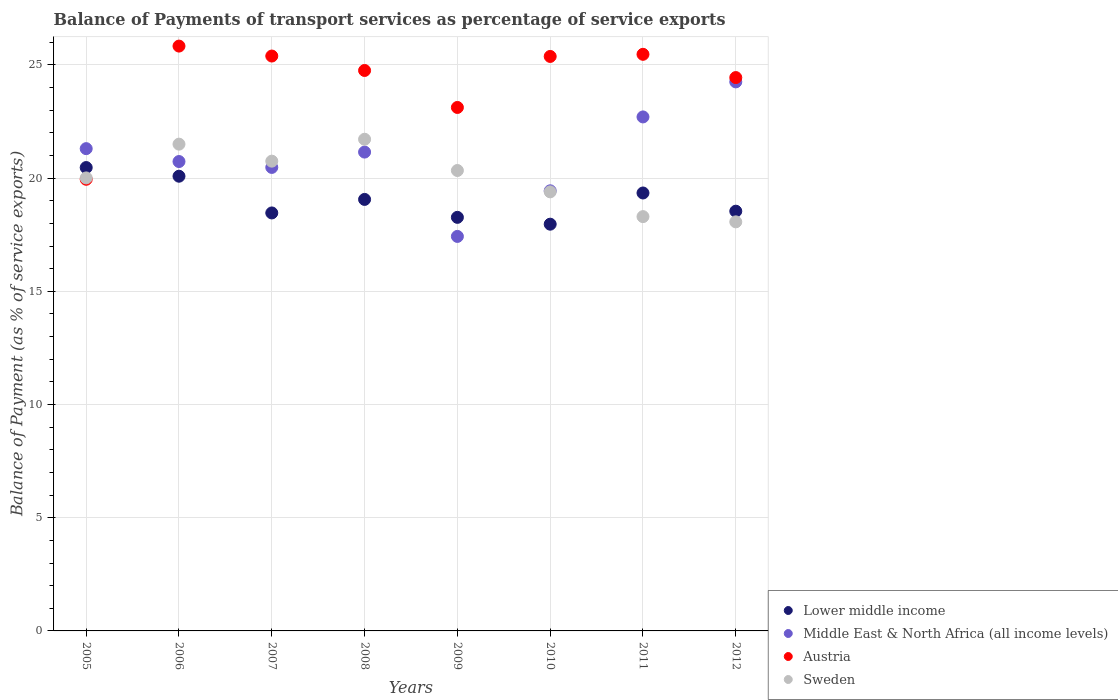What is the balance of payments of transport services in Austria in 2005?
Ensure brevity in your answer.  19.95. Across all years, what is the maximum balance of payments of transport services in Sweden?
Provide a succinct answer. 21.72. Across all years, what is the minimum balance of payments of transport services in Middle East & North Africa (all income levels)?
Keep it short and to the point. 17.43. What is the total balance of payments of transport services in Austria in the graph?
Make the answer very short. 194.33. What is the difference between the balance of payments of transport services in Lower middle income in 2006 and that in 2012?
Make the answer very short. 1.55. What is the difference between the balance of payments of transport services in Lower middle income in 2005 and the balance of payments of transport services in Middle East & North Africa (all income levels) in 2007?
Provide a short and direct response. -0.01. What is the average balance of payments of transport services in Middle East & North Africa (all income levels) per year?
Offer a very short reply. 20.93. In the year 2012, what is the difference between the balance of payments of transport services in Middle East & North Africa (all income levels) and balance of payments of transport services in Austria?
Offer a terse response. -0.19. What is the ratio of the balance of payments of transport services in Lower middle income in 2008 to that in 2012?
Provide a succinct answer. 1.03. Is the balance of payments of transport services in Austria in 2008 less than that in 2010?
Your answer should be very brief. Yes. Is the difference between the balance of payments of transport services in Middle East & North Africa (all income levels) in 2005 and 2010 greater than the difference between the balance of payments of transport services in Austria in 2005 and 2010?
Provide a short and direct response. Yes. What is the difference between the highest and the second highest balance of payments of transport services in Sweden?
Make the answer very short. 0.22. What is the difference between the highest and the lowest balance of payments of transport services in Sweden?
Your response must be concise. 3.65. Is the sum of the balance of payments of transport services in Middle East & North Africa (all income levels) in 2006 and 2008 greater than the maximum balance of payments of transport services in Sweden across all years?
Ensure brevity in your answer.  Yes. Is it the case that in every year, the sum of the balance of payments of transport services in Middle East & North Africa (all income levels) and balance of payments of transport services in Lower middle income  is greater than the sum of balance of payments of transport services in Austria and balance of payments of transport services in Sweden?
Provide a succinct answer. No. Is it the case that in every year, the sum of the balance of payments of transport services in Lower middle income and balance of payments of transport services in Middle East & North Africa (all income levels)  is greater than the balance of payments of transport services in Austria?
Provide a succinct answer. Yes. Is the balance of payments of transport services in Sweden strictly greater than the balance of payments of transport services in Austria over the years?
Offer a very short reply. No. Is the balance of payments of transport services in Middle East & North Africa (all income levels) strictly less than the balance of payments of transport services in Austria over the years?
Ensure brevity in your answer.  No. How many years are there in the graph?
Your answer should be compact. 8. What is the difference between two consecutive major ticks on the Y-axis?
Give a very brief answer. 5. Are the values on the major ticks of Y-axis written in scientific E-notation?
Offer a very short reply. No. Does the graph contain any zero values?
Offer a very short reply. No. Does the graph contain grids?
Keep it short and to the point. Yes. Where does the legend appear in the graph?
Make the answer very short. Bottom right. What is the title of the graph?
Make the answer very short. Balance of Payments of transport services as percentage of service exports. What is the label or title of the X-axis?
Provide a succinct answer. Years. What is the label or title of the Y-axis?
Your answer should be compact. Balance of Payment (as % of service exports). What is the Balance of Payment (as % of service exports) of Lower middle income in 2005?
Your answer should be compact. 20.47. What is the Balance of Payment (as % of service exports) of Middle East & North Africa (all income levels) in 2005?
Make the answer very short. 21.3. What is the Balance of Payment (as % of service exports) in Austria in 2005?
Give a very brief answer. 19.95. What is the Balance of Payment (as % of service exports) of Sweden in 2005?
Ensure brevity in your answer.  20.01. What is the Balance of Payment (as % of service exports) of Lower middle income in 2006?
Ensure brevity in your answer.  20.08. What is the Balance of Payment (as % of service exports) of Middle East & North Africa (all income levels) in 2006?
Provide a succinct answer. 20.73. What is the Balance of Payment (as % of service exports) of Austria in 2006?
Your answer should be very brief. 25.83. What is the Balance of Payment (as % of service exports) of Sweden in 2006?
Ensure brevity in your answer.  21.5. What is the Balance of Payment (as % of service exports) in Lower middle income in 2007?
Your answer should be compact. 18.46. What is the Balance of Payment (as % of service exports) in Middle East & North Africa (all income levels) in 2007?
Provide a short and direct response. 20.47. What is the Balance of Payment (as % of service exports) of Austria in 2007?
Ensure brevity in your answer.  25.39. What is the Balance of Payment (as % of service exports) in Sweden in 2007?
Your response must be concise. 20.75. What is the Balance of Payment (as % of service exports) of Lower middle income in 2008?
Keep it short and to the point. 19.06. What is the Balance of Payment (as % of service exports) in Middle East & North Africa (all income levels) in 2008?
Provide a short and direct response. 21.15. What is the Balance of Payment (as % of service exports) of Austria in 2008?
Your answer should be very brief. 24.75. What is the Balance of Payment (as % of service exports) in Sweden in 2008?
Keep it short and to the point. 21.72. What is the Balance of Payment (as % of service exports) of Lower middle income in 2009?
Ensure brevity in your answer.  18.27. What is the Balance of Payment (as % of service exports) of Middle East & North Africa (all income levels) in 2009?
Ensure brevity in your answer.  17.43. What is the Balance of Payment (as % of service exports) in Austria in 2009?
Make the answer very short. 23.12. What is the Balance of Payment (as % of service exports) in Sweden in 2009?
Offer a terse response. 20.34. What is the Balance of Payment (as % of service exports) in Lower middle income in 2010?
Your answer should be very brief. 17.97. What is the Balance of Payment (as % of service exports) in Middle East & North Africa (all income levels) in 2010?
Provide a succinct answer. 19.44. What is the Balance of Payment (as % of service exports) of Austria in 2010?
Give a very brief answer. 25.37. What is the Balance of Payment (as % of service exports) of Sweden in 2010?
Your answer should be compact. 19.39. What is the Balance of Payment (as % of service exports) in Lower middle income in 2011?
Make the answer very short. 19.34. What is the Balance of Payment (as % of service exports) of Middle East & North Africa (all income levels) in 2011?
Provide a succinct answer. 22.7. What is the Balance of Payment (as % of service exports) of Austria in 2011?
Provide a short and direct response. 25.47. What is the Balance of Payment (as % of service exports) of Sweden in 2011?
Ensure brevity in your answer.  18.3. What is the Balance of Payment (as % of service exports) of Lower middle income in 2012?
Your response must be concise. 18.54. What is the Balance of Payment (as % of service exports) in Middle East & North Africa (all income levels) in 2012?
Your answer should be compact. 24.25. What is the Balance of Payment (as % of service exports) in Austria in 2012?
Ensure brevity in your answer.  24.44. What is the Balance of Payment (as % of service exports) of Sweden in 2012?
Keep it short and to the point. 18.07. Across all years, what is the maximum Balance of Payment (as % of service exports) in Lower middle income?
Offer a terse response. 20.47. Across all years, what is the maximum Balance of Payment (as % of service exports) in Middle East & North Africa (all income levels)?
Provide a succinct answer. 24.25. Across all years, what is the maximum Balance of Payment (as % of service exports) in Austria?
Your response must be concise. 25.83. Across all years, what is the maximum Balance of Payment (as % of service exports) of Sweden?
Ensure brevity in your answer.  21.72. Across all years, what is the minimum Balance of Payment (as % of service exports) of Lower middle income?
Ensure brevity in your answer.  17.97. Across all years, what is the minimum Balance of Payment (as % of service exports) of Middle East & North Africa (all income levels)?
Your answer should be compact. 17.43. Across all years, what is the minimum Balance of Payment (as % of service exports) of Austria?
Give a very brief answer. 19.95. Across all years, what is the minimum Balance of Payment (as % of service exports) of Sweden?
Keep it short and to the point. 18.07. What is the total Balance of Payment (as % of service exports) in Lower middle income in the graph?
Your answer should be compact. 152.19. What is the total Balance of Payment (as % of service exports) of Middle East & North Africa (all income levels) in the graph?
Your answer should be very brief. 167.48. What is the total Balance of Payment (as % of service exports) in Austria in the graph?
Make the answer very short. 194.33. What is the total Balance of Payment (as % of service exports) in Sweden in the graph?
Your answer should be very brief. 160.07. What is the difference between the Balance of Payment (as % of service exports) in Lower middle income in 2005 and that in 2006?
Your answer should be very brief. 0.38. What is the difference between the Balance of Payment (as % of service exports) of Middle East & North Africa (all income levels) in 2005 and that in 2006?
Give a very brief answer. 0.57. What is the difference between the Balance of Payment (as % of service exports) in Austria in 2005 and that in 2006?
Your answer should be very brief. -5.88. What is the difference between the Balance of Payment (as % of service exports) in Sweden in 2005 and that in 2006?
Offer a terse response. -1.49. What is the difference between the Balance of Payment (as % of service exports) of Lower middle income in 2005 and that in 2007?
Ensure brevity in your answer.  2. What is the difference between the Balance of Payment (as % of service exports) in Middle East & North Africa (all income levels) in 2005 and that in 2007?
Your response must be concise. 0.83. What is the difference between the Balance of Payment (as % of service exports) of Austria in 2005 and that in 2007?
Offer a very short reply. -5.44. What is the difference between the Balance of Payment (as % of service exports) of Sweden in 2005 and that in 2007?
Your answer should be very brief. -0.74. What is the difference between the Balance of Payment (as % of service exports) in Lower middle income in 2005 and that in 2008?
Your answer should be compact. 1.41. What is the difference between the Balance of Payment (as % of service exports) in Middle East & North Africa (all income levels) in 2005 and that in 2008?
Make the answer very short. 0.15. What is the difference between the Balance of Payment (as % of service exports) of Austria in 2005 and that in 2008?
Ensure brevity in your answer.  -4.81. What is the difference between the Balance of Payment (as % of service exports) in Sweden in 2005 and that in 2008?
Your response must be concise. -1.71. What is the difference between the Balance of Payment (as % of service exports) in Lower middle income in 2005 and that in 2009?
Offer a terse response. 2.2. What is the difference between the Balance of Payment (as % of service exports) of Middle East & North Africa (all income levels) in 2005 and that in 2009?
Ensure brevity in your answer.  3.88. What is the difference between the Balance of Payment (as % of service exports) of Austria in 2005 and that in 2009?
Offer a terse response. -3.17. What is the difference between the Balance of Payment (as % of service exports) in Sweden in 2005 and that in 2009?
Your answer should be very brief. -0.33. What is the difference between the Balance of Payment (as % of service exports) of Lower middle income in 2005 and that in 2010?
Your answer should be very brief. 2.5. What is the difference between the Balance of Payment (as % of service exports) in Middle East & North Africa (all income levels) in 2005 and that in 2010?
Keep it short and to the point. 1.86. What is the difference between the Balance of Payment (as % of service exports) in Austria in 2005 and that in 2010?
Make the answer very short. -5.43. What is the difference between the Balance of Payment (as % of service exports) of Sweden in 2005 and that in 2010?
Give a very brief answer. 0.62. What is the difference between the Balance of Payment (as % of service exports) in Lower middle income in 2005 and that in 2011?
Your answer should be compact. 1.12. What is the difference between the Balance of Payment (as % of service exports) of Middle East & North Africa (all income levels) in 2005 and that in 2011?
Provide a short and direct response. -1.4. What is the difference between the Balance of Payment (as % of service exports) of Austria in 2005 and that in 2011?
Provide a short and direct response. -5.52. What is the difference between the Balance of Payment (as % of service exports) in Sweden in 2005 and that in 2011?
Offer a very short reply. 1.71. What is the difference between the Balance of Payment (as % of service exports) in Lower middle income in 2005 and that in 2012?
Give a very brief answer. 1.93. What is the difference between the Balance of Payment (as % of service exports) of Middle East & North Africa (all income levels) in 2005 and that in 2012?
Provide a short and direct response. -2.95. What is the difference between the Balance of Payment (as % of service exports) in Austria in 2005 and that in 2012?
Give a very brief answer. -4.49. What is the difference between the Balance of Payment (as % of service exports) of Sweden in 2005 and that in 2012?
Offer a very short reply. 1.94. What is the difference between the Balance of Payment (as % of service exports) of Lower middle income in 2006 and that in 2007?
Give a very brief answer. 1.62. What is the difference between the Balance of Payment (as % of service exports) of Middle East & North Africa (all income levels) in 2006 and that in 2007?
Your answer should be compact. 0.26. What is the difference between the Balance of Payment (as % of service exports) of Austria in 2006 and that in 2007?
Give a very brief answer. 0.44. What is the difference between the Balance of Payment (as % of service exports) in Sweden in 2006 and that in 2007?
Offer a terse response. 0.75. What is the difference between the Balance of Payment (as % of service exports) of Lower middle income in 2006 and that in 2008?
Your answer should be compact. 1.02. What is the difference between the Balance of Payment (as % of service exports) of Middle East & North Africa (all income levels) in 2006 and that in 2008?
Provide a succinct answer. -0.42. What is the difference between the Balance of Payment (as % of service exports) in Austria in 2006 and that in 2008?
Your answer should be compact. 1.08. What is the difference between the Balance of Payment (as % of service exports) of Sweden in 2006 and that in 2008?
Ensure brevity in your answer.  -0.22. What is the difference between the Balance of Payment (as % of service exports) of Lower middle income in 2006 and that in 2009?
Your answer should be very brief. 1.82. What is the difference between the Balance of Payment (as % of service exports) of Middle East & North Africa (all income levels) in 2006 and that in 2009?
Provide a short and direct response. 3.31. What is the difference between the Balance of Payment (as % of service exports) in Austria in 2006 and that in 2009?
Provide a short and direct response. 2.71. What is the difference between the Balance of Payment (as % of service exports) in Sweden in 2006 and that in 2009?
Make the answer very short. 1.16. What is the difference between the Balance of Payment (as % of service exports) in Lower middle income in 2006 and that in 2010?
Your answer should be compact. 2.12. What is the difference between the Balance of Payment (as % of service exports) in Middle East & North Africa (all income levels) in 2006 and that in 2010?
Your answer should be compact. 1.29. What is the difference between the Balance of Payment (as % of service exports) in Austria in 2006 and that in 2010?
Provide a succinct answer. 0.46. What is the difference between the Balance of Payment (as % of service exports) of Sweden in 2006 and that in 2010?
Your response must be concise. 2.11. What is the difference between the Balance of Payment (as % of service exports) of Lower middle income in 2006 and that in 2011?
Your response must be concise. 0.74. What is the difference between the Balance of Payment (as % of service exports) in Middle East & North Africa (all income levels) in 2006 and that in 2011?
Offer a terse response. -1.97. What is the difference between the Balance of Payment (as % of service exports) of Austria in 2006 and that in 2011?
Give a very brief answer. 0.36. What is the difference between the Balance of Payment (as % of service exports) in Sweden in 2006 and that in 2011?
Your response must be concise. 3.2. What is the difference between the Balance of Payment (as % of service exports) in Lower middle income in 2006 and that in 2012?
Your response must be concise. 1.54. What is the difference between the Balance of Payment (as % of service exports) of Middle East & North Africa (all income levels) in 2006 and that in 2012?
Provide a short and direct response. -3.52. What is the difference between the Balance of Payment (as % of service exports) in Austria in 2006 and that in 2012?
Offer a terse response. 1.39. What is the difference between the Balance of Payment (as % of service exports) in Sweden in 2006 and that in 2012?
Offer a very short reply. 3.43. What is the difference between the Balance of Payment (as % of service exports) in Lower middle income in 2007 and that in 2008?
Offer a very short reply. -0.6. What is the difference between the Balance of Payment (as % of service exports) of Middle East & North Africa (all income levels) in 2007 and that in 2008?
Offer a terse response. -0.68. What is the difference between the Balance of Payment (as % of service exports) in Austria in 2007 and that in 2008?
Make the answer very short. 0.64. What is the difference between the Balance of Payment (as % of service exports) in Sweden in 2007 and that in 2008?
Provide a succinct answer. -0.97. What is the difference between the Balance of Payment (as % of service exports) in Lower middle income in 2007 and that in 2009?
Provide a short and direct response. 0.19. What is the difference between the Balance of Payment (as % of service exports) of Middle East & North Africa (all income levels) in 2007 and that in 2009?
Ensure brevity in your answer.  3.05. What is the difference between the Balance of Payment (as % of service exports) of Austria in 2007 and that in 2009?
Make the answer very short. 2.27. What is the difference between the Balance of Payment (as % of service exports) of Sweden in 2007 and that in 2009?
Your answer should be very brief. 0.41. What is the difference between the Balance of Payment (as % of service exports) of Lower middle income in 2007 and that in 2010?
Give a very brief answer. 0.5. What is the difference between the Balance of Payment (as % of service exports) of Middle East & North Africa (all income levels) in 2007 and that in 2010?
Ensure brevity in your answer.  1.03. What is the difference between the Balance of Payment (as % of service exports) of Austria in 2007 and that in 2010?
Your answer should be very brief. 0.02. What is the difference between the Balance of Payment (as % of service exports) in Sweden in 2007 and that in 2010?
Provide a short and direct response. 1.36. What is the difference between the Balance of Payment (as % of service exports) of Lower middle income in 2007 and that in 2011?
Ensure brevity in your answer.  -0.88. What is the difference between the Balance of Payment (as % of service exports) of Middle East & North Africa (all income levels) in 2007 and that in 2011?
Offer a very short reply. -2.23. What is the difference between the Balance of Payment (as % of service exports) in Austria in 2007 and that in 2011?
Ensure brevity in your answer.  -0.08. What is the difference between the Balance of Payment (as % of service exports) in Sweden in 2007 and that in 2011?
Make the answer very short. 2.45. What is the difference between the Balance of Payment (as % of service exports) of Lower middle income in 2007 and that in 2012?
Your answer should be very brief. -0.08. What is the difference between the Balance of Payment (as % of service exports) of Middle East & North Africa (all income levels) in 2007 and that in 2012?
Your response must be concise. -3.78. What is the difference between the Balance of Payment (as % of service exports) of Austria in 2007 and that in 2012?
Your response must be concise. 0.95. What is the difference between the Balance of Payment (as % of service exports) in Sweden in 2007 and that in 2012?
Your answer should be compact. 2.68. What is the difference between the Balance of Payment (as % of service exports) in Lower middle income in 2008 and that in 2009?
Your answer should be very brief. 0.79. What is the difference between the Balance of Payment (as % of service exports) in Middle East & North Africa (all income levels) in 2008 and that in 2009?
Your answer should be compact. 3.72. What is the difference between the Balance of Payment (as % of service exports) of Austria in 2008 and that in 2009?
Ensure brevity in your answer.  1.63. What is the difference between the Balance of Payment (as % of service exports) in Sweden in 2008 and that in 2009?
Keep it short and to the point. 1.38. What is the difference between the Balance of Payment (as % of service exports) in Lower middle income in 2008 and that in 2010?
Your response must be concise. 1.09. What is the difference between the Balance of Payment (as % of service exports) in Middle East & North Africa (all income levels) in 2008 and that in 2010?
Keep it short and to the point. 1.71. What is the difference between the Balance of Payment (as % of service exports) of Austria in 2008 and that in 2010?
Your response must be concise. -0.62. What is the difference between the Balance of Payment (as % of service exports) of Sweden in 2008 and that in 2010?
Your answer should be very brief. 2.32. What is the difference between the Balance of Payment (as % of service exports) in Lower middle income in 2008 and that in 2011?
Keep it short and to the point. -0.28. What is the difference between the Balance of Payment (as % of service exports) of Middle East & North Africa (all income levels) in 2008 and that in 2011?
Keep it short and to the point. -1.55. What is the difference between the Balance of Payment (as % of service exports) of Austria in 2008 and that in 2011?
Provide a succinct answer. -0.71. What is the difference between the Balance of Payment (as % of service exports) in Sweden in 2008 and that in 2011?
Ensure brevity in your answer.  3.42. What is the difference between the Balance of Payment (as % of service exports) of Lower middle income in 2008 and that in 2012?
Make the answer very short. 0.52. What is the difference between the Balance of Payment (as % of service exports) of Middle East & North Africa (all income levels) in 2008 and that in 2012?
Provide a succinct answer. -3.1. What is the difference between the Balance of Payment (as % of service exports) in Austria in 2008 and that in 2012?
Provide a succinct answer. 0.31. What is the difference between the Balance of Payment (as % of service exports) in Sweden in 2008 and that in 2012?
Offer a very short reply. 3.65. What is the difference between the Balance of Payment (as % of service exports) in Lower middle income in 2009 and that in 2010?
Provide a succinct answer. 0.3. What is the difference between the Balance of Payment (as % of service exports) in Middle East & North Africa (all income levels) in 2009 and that in 2010?
Keep it short and to the point. -2.01. What is the difference between the Balance of Payment (as % of service exports) in Austria in 2009 and that in 2010?
Your answer should be compact. -2.25. What is the difference between the Balance of Payment (as % of service exports) of Sweden in 2009 and that in 2010?
Offer a terse response. 0.94. What is the difference between the Balance of Payment (as % of service exports) of Lower middle income in 2009 and that in 2011?
Ensure brevity in your answer.  -1.08. What is the difference between the Balance of Payment (as % of service exports) of Middle East & North Africa (all income levels) in 2009 and that in 2011?
Ensure brevity in your answer.  -5.28. What is the difference between the Balance of Payment (as % of service exports) in Austria in 2009 and that in 2011?
Provide a short and direct response. -2.35. What is the difference between the Balance of Payment (as % of service exports) in Sweden in 2009 and that in 2011?
Provide a short and direct response. 2.04. What is the difference between the Balance of Payment (as % of service exports) of Lower middle income in 2009 and that in 2012?
Offer a terse response. -0.27. What is the difference between the Balance of Payment (as % of service exports) in Middle East & North Africa (all income levels) in 2009 and that in 2012?
Offer a very short reply. -6.83. What is the difference between the Balance of Payment (as % of service exports) in Austria in 2009 and that in 2012?
Your answer should be compact. -1.32. What is the difference between the Balance of Payment (as % of service exports) in Sweden in 2009 and that in 2012?
Keep it short and to the point. 2.27. What is the difference between the Balance of Payment (as % of service exports) in Lower middle income in 2010 and that in 2011?
Your answer should be compact. -1.38. What is the difference between the Balance of Payment (as % of service exports) of Middle East & North Africa (all income levels) in 2010 and that in 2011?
Your response must be concise. -3.26. What is the difference between the Balance of Payment (as % of service exports) of Austria in 2010 and that in 2011?
Make the answer very short. -0.09. What is the difference between the Balance of Payment (as % of service exports) in Sweden in 2010 and that in 2011?
Keep it short and to the point. 1.09. What is the difference between the Balance of Payment (as % of service exports) of Lower middle income in 2010 and that in 2012?
Provide a short and direct response. -0.57. What is the difference between the Balance of Payment (as % of service exports) of Middle East & North Africa (all income levels) in 2010 and that in 2012?
Your answer should be very brief. -4.81. What is the difference between the Balance of Payment (as % of service exports) in Austria in 2010 and that in 2012?
Make the answer very short. 0.93. What is the difference between the Balance of Payment (as % of service exports) of Sweden in 2010 and that in 2012?
Provide a short and direct response. 1.32. What is the difference between the Balance of Payment (as % of service exports) of Lower middle income in 2011 and that in 2012?
Your answer should be very brief. 0.8. What is the difference between the Balance of Payment (as % of service exports) of Middle East & North Africa (all income levels) in 2011 and that in 2012?
Make the answer very short. -1.55. What is the difference between the Balance of Payment (as % of service exports) of Austria in 2011 and that in 2012?
Provide a succinct answer. 1.03. What is the difference between the Balance of Payment (as % of service exports) in Sweden in 2011 and that in 2012?
Your response must be concise. 0.23. What is the difference between the Balance of Payment (as % of service exports) in Lower middle income in 2005 and the Balance of Payment (as % of service exports) in Middle East & North Africa (all income levels) in 2006?
Keep it short and to the point. -0.27. What is the difference between the Balance of Payment (as % of service exports) in Lower middle income in 2005 and the Balance of Payment (as % of service exports) in Austria in 2006?
Make the answer very short. -5.37. What is the difference between the Balance of Payment (as % of service exports) in Lower middle income in 2005 and the Balance of Payment (as % of service exports) in Sweden in 2006?
Your response must be concise. -1.03. What is the difference between the Balance of Payment (as % of service exports) in Middle East & North Africa (all income levels) in 2005 and the Balance of Payment (as % of service exports) in Austria in 2006?
Your response must be concise. -4.53. What is the difference between the Balance of Payment (as % of service exports) of Middle East & North Africa (all income levels) in 2005 and the Balance of Payment (as % of service exports) of Sweden in 2006?
Ensure brevity in your answer.  -0.2. What is the difference between the Balance of Payment (as % of service exports) in Austria in 2005 and the Balance of Payment (as % of service exports) in Sweden in 2006?
Your answer should be compact. -1.55. What is the difference between the Balance of Payment (as % of service exports) of Lower middle income in 2005 and the Balance of Payment (as % of service exports) of Middle East & North Africa (all income levels) in 2007?
Keep it short and to the point. -0.01. What is the difference between the Balance of Payment (as % of service exports) in Lower middle income in 2005 and the Balance of Payment (as % of service exports) in Austria in 2007?
Provide a short and direct response. -4.93. What is the difference between the Balance of Payment (as % of service exports) in Lower middle income in 2005 and the Balance of Payment (as % of service exports) in Sweden in 2007?
Your response must be concise. -0.28. What is the difference between the Balance of Payment (as % of service exports) in Middle East & North Africa (all income levels) in 2005 and the Balance of Payment (as % of service exports) in Austria in 2007?
Provide a succinct answer. -4.09. What is the difference between the Balance of Payment (as % of service exports) of Middle East & North Africa (all income levels) in 2005 and the Balance of Payment (as % of service exports) of Sweden in 2007?
Provide a succinct answer. 0.55. What is the difference between the Balance of Payment (as % of service exports) in Austria in 2005 and the Balance of Payment (as % of service exports) in Sweden in 2007?
Provide a short and direct response. -0.8. What is the difference between the Balance of Payment (as % of service exports) of Lower middle income in 2005 and the Balance of Payment (as % of service exports) of Middle East & North Africa (all income levels) in 2008?
Offer a very short reply. -0.68. What is the difference between the Balance of Payment (as % of service exports) in Lower middle income in 2005 and the Balance of Payment (as % of service exports) in Austria in 2008?
Provide a succinct answer. -4.29. What is the difference between the Balance of Payment (as % of service exports) of Lower middle income in 2005 and the Balance of Payment (as % of service exports) of Sweden in 2008?
Make the answer very short. -1.25. What is the difference between the Balance of Payment (as % of service exports) in Middle East & North Africa (all income levels) in 2005 and the Balance of Payment (as % of service exports) in Austria in 2008?
Make the answer very short. -3.45. What is the difference between the Balance of Payment (as % of service exports) in Middle East & North Africa (all income levels) in 2005 and the Balance of Payment (as % of service exports) in Sweden in 2008?
Provide a succinct answer. -0.41. What is the difference between the Balance of Payment (as % of service exports) in Austria in 2005 and the Balance of Payment (as % of service exports) in Sweden in 2008?
Your answer should be very brief. -1.77. What is the difference between the Balance of Payment (as % of service exports) of Lower middle income in 2005 and the Balance of Payment (as % of service exports) of Middle East & North Africa (all income levels) in 2009?
Ensure brevity in your answer.  3.04. What is the difference between the Balance of Payment (as % of service exports) in Lower middle income in 2005 and the Balance of Payment (as % of service exports) in Austria in 2009?
Make the answer very short. -2.65. What is the difference between the Balance of Payment (as % of service exports) of Lower middle income in 2005 and the Balance of Payment (as % of service exports) of Sweden in 2009?
Provide a succinct answer. 0.13. What is the difference between the Balance of Payment (as % of service exports) in Middle East & North Africa (all income levels) in 2005 and the Balance of Payment (as % of service exports) in Austria in 2009?
Offer a very short reply. -1.82. What is the difference between the Balance of Payment (as % of service exports) in Middle East & North Africa (all income levels) in 2005 and the Balance of Payment (as % of service exports) in Sweden in 2009?
Offer a very short reply. 0.97. What is the difference between the Balance of Payment (as % of service exports) of Austria in 2005 and the Balance of Payment (as % of service exports) of Sweden in 2009?
Offer a very short reply. -0.39. What is the difference between the Balance of Payment (as % of service exports) of Lower middle income in 2005 and the Balance of Payment (as % of service exports) of Austria in 2010?
Make the answer very short. -4.91. What is the difference between the Balance of Payment (as % of service exports) of Lower middle income in 2005 and the Balance of Payment (as % of service exports) of Sweden in 2010?
Offer a very short reply. 1.07. What is the difference between the Balance of Payment (as % of service exports) of Middle East & North Africa (all income levels) in 2005 and the Balance of Payment (as % of service exports) of Austria in 2010?
Keep it short and to the point. -4.07. What is the difference between the Balance of Payment (as % of service exports) of Middle East & North Africa (all income levels) in 2005 and the Balance of Payment (as % of service exports) of Sweden in 2010?
Make the answer very short. 1.91. What is the difference between the Balance of Payment (as % of service exports) in Austria in 2005 and the Balance of Payment (as % of service exports) in Sweden in 2010?
Give a very brief answer. 0.56. What is the difference between the Balance of Payment (as % of service exports) in Lower middle income in 2005 and the Balance of Payment (as % of service exports) in Middle East & North Africa (all income levels) in 2011?
Give a very brief answer. -2.24. What is the difference between the Balance of Payment (as % of service exports) in Lower middle income in 2005 and the Balance of Payment (as % of service exports) in Austria in 2011?
Provide a short and direct response. -5. What is the difference between the Balance of Payment (as % of service exports) of Lower middle income in 2005 and the Balance of Payment (as % of service exports) of Sweden in 2011?
Give a very brief answer. 2.17. What is the difference between the Balance of Payment (as % of service exports) of Middle East & North Africa (all income levels) in 2005 and the Balance of Payment (as % of service exports) of Austria in 2011?
Offer a very short reply. -4.17. What is the difference between the Balance of Payment (as % of service exports) in Middle East & North Africa (all income levels) in 2005 and the Balance of Payment (as % of service exports) in Sweden in 2011?
Offer a terse response. 3. What is the difference between the Balance of Payment (as % of service exports) of Austria in 2005 and the Balance of Payment (as % of service exports) of Sweden in 2011?
Your answer should be very brief. 1.65. What is the difference between the Balance of Payment (as % of service exports) in Lower middle income in 2005 and the Balance of Payment (as % of service exports) in Middle East & North Africa (all income levels) in 2012?
Offer a very short reply. -3.78. What is the difference between the Balance of Payment (as % of service exports) in Lower middle income in 2005 and the Balance of Payment (as % of service exports) in Austria in 2012?
Your response must be concise. -3.97. What is the difference between the Balance of Payment (as % of service exports) in Lower middle income in 2005 and the Balance of Payment (as % of service exports) in Sweden in 2012?
Ensure brevity in your answer.  2.4. What is the difference between the Balance of Payment (as % of service exports) in Middle East & North Africa (all income levels) in 2005 and the Balance of Payment (as % of service exports) in Austria in 2012?
Provide a short and direct response. -3.14. What is the difference between the Balance of Payment (as % of service exports) in Middle East & North Africa (all income levels) in 2005 and the Balance of Payment (as % of service exports) in Sweden in 2012?
Make the answer very short. 3.23. What is the difference between the Balance of Payment (as % of service exports) of Austria in 2005 and the Balance of Payment (as % of service exports) of Sweden in 2012?
Make the answer very short. 1.88. What is the difference between the Balance of Payment (as % of service exports) in Lower middle income in 2006 and the Balance of Payment (as % of service exports) in Middle East & North Africa (all income levels) in 2007?
Your response must be concise. -0.39. What is the difference between the Balance of Payment (as % of service exports) of Lower middle income in 2006 and the Balance of Payment (as % of service exports) of Austria in 2007?
Your response must be concise. -5.31. What is the difference between the Balance of Payment (as % of service exports) of Lower middle income in 2006 and the Balance of Payment (as % of service exports) of Sweden in 2007?
Keep it short and to the point. -0.67. What is the difference between the Balance of Payment (as % of service exports) in Middle East & North Africa (all income levels) in 2006 and the Balance of Payment (as % of service exports) in Austria in 2007?
Make the answer very short. -4.66. What is the difference between the Balance of Payment (as % of service exports) of Middle East & North Africa (all income levels) in 2006 and the Balance of Payment (as % of service exports) of Sweden in 2007?
Provide a succinct answer. -0.02. What is the difference between the Balance of Payment (as % of service exports) in Austria in 2006 and the Balance of Payment (as % of service exports) in Sweden in 2007?
Provide a succinct answer. 5.08. What is the difference between the Balance of Payment (as % of service exports) of Lower middle income in 2006 and the Balance of Payment (as % of service exports) of Middle East & North Africa (all income levels) in 2008?
Offer a very short reply. -1.07. What is the difference between the Balance of Payment (as % of service exports) of Lower middle income in 2006 and the Balance of Payment (as % of service exports) of Austria in 2008?
Provide a succinct answer. -4.67. What is the difference between the Balance of Payment (as % of service exports) of Lower middle income in 2006 and the Balance of Payment (as % of service exports) of Sweden in 2008?
Provide a succinct answer. -1.63. What is the difference between the Balance of Payment (as % of service exports) in Middle East & North Africa (all income levels) in 2006 and the Balance of Payment (as % of service exports) in Austria in 2008?
Make the answer very short. -4.02. What is the difference between the Balance of Payment (as % of service exports) in Middle East & North Africa (all income levels) in 2006 and the Balance of Payment (as % of service exports) in Sweden in 2008?
Your answer should be compact. -0.98. What is the difference between the Balance of Payment (as % of service exports) of Austria in 2006 and the Balance of Payment (as % of service exports) of Sweden in 2008?
Your answer should be very brief. 4.12. What is the difference between the Balance of Payment (as % of service exports) in Lower middle income in 2006 and the Balance of Payment (as % of service exports) in Middle East & North Africa (all income levels) in 2009?
Offer a terse response. 2.66. What is the difference between the Balance of Payment (as % of service exports) of Lower middle income in 2006 and the Balance of Payment (as % of service exports) of Austria in 2009?
Make the answer very short. -3.04. What is the difference between the Balance of Payment (as % of service exports) in Lower middle income in 2006 and the Balance of Payment (as % of service exports) in Sweden in 2009?
Give a very brief answer. -0.25. What is the difference between the Balance of Payment (as % of service exports) in Middle East & North Africa (all income levels) in 2006 and the Balance of Payment (as % of service exports) in Austria in 2009?
Provide a succinct answer. -2.39. What is the difference between the Balance of Payment (as % of service exports) of Middle East & North Africa (all income levels) in 2006 and the Balance of Payment (as % of service exports) of Sweden in 2009?
Keep it short and to the point. 0.4. What is the difference between the Balance of Payment (as % of service exports) of Austria in 2006 and the Balance of Payment (as % of service exports) of Sweden in 2009?
Your answer should be compact. 5.5. What is the difference between the Balance of Payment (as % of service exports) in Lower middle income in 2006 and the Balance of Payment (as % of service exports) in Middle East & North Africa (all income levels) in 2010?
Give a very brief answer. 0.64. What is the difference between the Balance of Payment (as % of service exports) of Lower middle income in 2006 and the Balance of Payment (as % of service exports) of Austria in 2010?
Your answer should be very brief. -5.29. What is the difference between the Balance of Payment (as % of service exports) in Lower middle income in 2006 and the Balance of Payment (as % of service exports) in Sweden in 2010?
Provide a succinct answer. 0.69. What is the difference between the Balance of Payment (as % of service exports) of Middle East & North Africa (all income levels) in 2006 and the Balance of Payment (as % of service exports) of Austria in 2010?
Give a very brief answer. -4.64. What is the difference between the Balance of Payment (as % of service exports) in Middle East & North Africa (all income levels) in 2006 and the Balance of Payment (as % of service exports) in Sweden in 2010?
Give a very brief answer. 1.34. What is the difference between the Balance of Payment (as % of service exports) of Austria in 2006 and the Balance of Payment (as % of service exports) of Sweden in 2010?
Provide a succinct answer. 6.44. What is the difference between the Balance of Payment (as % of service exports) of Lower middle income in 2006 and the Balance of Payment (as % of service exports) of Middle East & North Africa (all income levels) in 2011?
Give a very brief answer. -2.62. What is the difference between the Balance of Payment (as % of service exports) in Lower middle income in 2006 and the Balance of Payment (as % of service exports) in Austria in 2011?
Make the answer very short. -5.38. What is the difference between the Balance of Payment (as % of service exports) of Lower middle income in 2006 and the Balance of Payment (as % of service exports) of Sweden in 2011?
Your answer should be very brief. 1.78. What is the difference between the Balance of Payment (as % of service exports) of Middle East & North Africa (all income levels) in 2006 and the Balance of Payment (as % of service exports) of Austria in 2011?
Give a very brief answer. -4.74. What is the difference between the Balance of Payment (as % of service exports) in Middle East & North Africa (all income levels) in 2006 and the Balance of Payment (as % of service exports) in Sweden in 2011?
Offer a terse response. 2.43. What is the difference between the Balance of Payment (as % of service exports) in Austria in 2006 and the Balance of Payment (as % of service exports) in Sweden in 2011?
Your answer should be very brief. 7.53. What is the difference between the Balance of Payment (as % of service exports) of Lower middle income in 2006 and the Balance of Payment (as % of service exports) of Middle East & North Africa (all income levels) in 2012?
Make the answer very short. -4.17. What is the difference between the Balance of Payment (as % of service exports) in Lower middle income in 2006 and the Balance of Payment (as % of service exports) in Austria in 2012?
Your answer should be very brief. -4.36. What is the difference between the Balance of Payment (as % of service exports) of Lower middle income in 2006 and the Balance of Payment (as % of service exports) of Sweden in 2012?
Your response must be concise. 2.02. What is the difference between the Balance of Payment (as % of service exports) of Middle East & North Africa (all income levels) in 2006 and the Balance of Payment (as % of service exports) of Austria in 2012?
Ensure brevity in your answer.  -3.71. What is the difference between the Balance of Payment (as % of service exports) in Middle East & North Africa (all income levels) in 2006 and the Balance of Payment (as % of service exports) in Sweden in 2012?
Your answer should be very brief. 2.66. What is the difference between the Balance of Payment (as % of service exports) of Austria in 2006 and the Balance of Payment (as % of service exports) of Sweden in 2012?
Your answer should be very brief. 7.76. What is the difference between the Balance of Payment (as % of service exports) in Lower middle income in 2007 and the Balance of Payment (as % of service exports) in Middle East & North Africa (all income levels) in 2008?
Give a very brief answer. -2.69. What is the difference between the Balance of Payment (as % of service exports) in Lower middle income in 2007 and the Balance of Payment (as % of service exports) in Austria in 2008?
Your answer should be compact. -6.29. What is the difference between the Balance of Payment (as % of service exports) in Lower middle income in 2007 and the Balance of Payment (as % of service exports) in Sweden in 2008?
Make the answer very short. -3.25. What is the difference between the Balance of Payment (as % of service exports) in Middle East & North Africa (all income levels) in 2007 and the Balance of Payment (as % of service exports) in Austria in 2008?
Your answer should be very brief. -4.28. What is the difference between the Balance of Payment (as % of service exports) in Middle East & North Africa (all income levels) in 2007 and the Balance of Payment (as % of service exports) in Sweden in 2008?
Offer a very short reply. -1.24. What is the difference between the Balance of Payment (as % of service exports) of Austria in 2007 and the Balance of Payment (as % of service exports) of Sweden in 2008?
Keep it short and to the point. 3.68. What is the difference between the Balance of Payment (as % of service exports) of Lower middle income in 2007 and the Balance of Payment (as % of service exports) of Middle East & North Africa (all income levels) in 2009?
Give a very brief answer. 1.04. What is the difference between the Balance of Payment (as % of service exports) in Lower middle income in 2007 and the Balance of Payment (as % of service exports) in Austria in 2009?
Make the answer very short. -4.66. What is the difference between the Balance of Payment (as % of service exports) in Lower middle income in 2007 and the Balance of Payment (as % of service exports) in Sweden in 2009?
Your answer should be very brief. -1.87. What is the difference between the Balance of Payment (as % of service exports) of Middle East & North Africa (all income levels) in 2007 and the Balance of Payment (as % of service exports) of Austria in 2009?
Give a very brief answer. -2.65. What is the difference between the Balance of Payment (as % of service exports) in Middle East & North Africa (all income levels) in 2007 and the Balance of Payment (as % of service exports) in Sweden in 2009?
Offer a terse response. 0.14. What is the difference between the Balance of Payment (as % of service exports) of Austria in 2007 and the Balance of Payment (as % of service exports) of Sweden in 2009?
Give a very brief answer. 5.06. What is the difference between the Balance of Payment (as % of service exports) of Lower middle income in 2007 and the Balance of Payment (as % of service exports) of Middle East & North Africa (all income levels) in 2010?
Keep it short and to the point. -0.98. What is the difference between the Balance of Payment (as % of service exports) in Lower middle income in 2007 and the Balance of Payment (as % of service exports) in Austria in 2010?
Your response must be concise. -6.91. What is the difference between the Balance of Payment (as % of service exports) of Lower middle income in 2007 and the Balance of Payment (as % of service exports) of Sweden in 2010?
Ensure brevity in your answer.  -0.93. What is the difference between the Balance of Payment (as % of service exports) of Middle East & North Africa (all income levels) in 2007 and the Balance of Payment (as % of service exports) of Austria in 2010?
Provide a short and direct response. -4.9. What is the difference between the Balance of Payment (as % of service exports) in Middle East & North Africa (all income levels) in 2007 and the Balance of Payment (as % of service exports) in Sweden in 2010?
Give a very brief answer. 1.08. What is the difference between the Balance of Payment (as % of service exports) in Austria in 2007 and the Balance of Payment (as % of service exports) in Sweden in 2010?
Ensure brevity in your answer.  6. What is the difference between the Balance of Payment (as % of service exports) in Lower middle income in 2007 and the Balance of Payment (as % of service exports) in Middle East & North Africa (all income levels) in 2011?
Make the answer very short. -4.24. What is the difference between the Balance of Payment (as % of service exports) in Lower middle income in 2007 and the Balance of Payment (as % of service exports) in Austria in 2011?
Your answer should be very brief. -7.01. What is the difference between the Balance of Payment (as % of service exports) of Lower middle income in 2007 and the Balance of Payment (as % of service exports) of Sweden in 2011?
Ensure brevity in your answer.  0.16. What is the difference between the Balance of Payment (as % of service exports) of Middle East & North Africa (all income levels) in 2007 and the Balance of Payment (as % of service exports) of Austria in 2011?
Provide a succinct answer. -5. What is the difference between the Balance of Payment (as % of service exports) of Middle East & North Africa (all income levels) in 2007 and the Balance of Payment (as % of service exports) of Sweden in 2011?
Keep it short and to the point. 2.17. What is the difference between the Balance of Payment (as % of service exports) in Austria in 2007 and the Balance of Payment (as % of service exports) in Sweden in 2011?
Your response must be concise. 7.09. What is the difference between the Balance of Payment (as % of service exports) of Lower middle income in 2007 and the Balance of Payment (as % of service exports) of Middle East & North Africa (all income levels) in 2012?
Your response must be concise. -5.79. What is the difference between the Balance of Payment (as % of service exports) of Lower middle income in 2007 and the Balance of Payment (as % of service exports) of Austria in 2012?
Make the answer very short. -5.98. What is the difference between the Balance of Payment (as % of service exports) in Lower middle income in 2007 and the Balance of Payment (as % of service exports) in Sweden in 2012?
Provide a short and direct response. 0.39. What is the difference between the Balance of Payment (as % of service exports) in Middle East & North Africa (all income levels) in 2007 and the Balance of Payment (as % of service exports) in Austria in 2012?
Your response must be concise. -3.97. What is the difference between the Balance of Payment (as % of service exports) of Middle East & North Africa (all income levels) in 2007 and the Balance of Payment (as % of service exports) of Sweden in 2012?
Your answer should be compact. 2.4. What is the difference between the Balance of Payment (as % of service exports) of Austria in 2007 and the Balance of Payment (as % of service exports) of Sweden in 2012?
Your response must be concise. 7.32. What is the difference between the Balance of Payment (as % of service exports) of Lower middle income in 2008 and the Balance of Payment (as % of service exports) of Middle East & North Africa (all income levels) in 2009?
Your answer should be very brief. 1.63. What is the difference between the Balance of Payment (as % of service exports) in Lower middle income in 2008 and the Balance of Payment (as % of service exports) in Austria in 2009?
Provide a succinct answer. -4.06. What is the difference between the Balance of Payment (as % of service exports) in Lower middle income in 2008 and the Balance of Payment (as % of service exports) in Sweden in 2009?
Provide a succinct answer. -1.28. What is the difference between the Balance of Payment (as % of service exports) of Middle East & North Africa (all income levels) in 2008 and the Balance of Payment (as % of service exports) of Austria in 2009?
Ensure brevity in your answer.  -1.97. What is the difference between the Balance of Payment (as % of service exports) of Middle East & North Africa (all income levels) in 2008 and the Balance of Payment (as % of service exports) of Sweden in 2009?
Keep it short and to the point. 0.81. What is the difference between the Balance of Payment (as % of service exports) in Austria in 2008 and the Balance of Payment (as % of service exports) in Sweden in 2009?
Your answer should be compact. 4.42. What is the difference between the Balance of Payment (as % of service exports) of Lower middle income in 2008 and the Balance of Payment (as % of service exports) of Middle East & North Africa (all income levels) in 2010?
Ensure brevity in your answer.  -0.38. What is the difference between the Balance of Payment (as % of service exports) of Lower middle income in 2008 and the Balance of Payment (as % of service exports) of Austria in 2010?
Ensure brevity in your answer.  -6.32. What is the difference between the Balance of Payment (as % of service exports) of Lower middle income in 2008 and the Balance of Payment (as % of service exports) of Sweden in 2010?
Provide a succinct answer. -0.33. What is the difference between the Balance of Payment (as % of service exports) of Middle East & North Africa (all income levels) in 2008 and the Balance of Payment (as % of service exports) of Austria in 2010?
Give a very brief answer. -4.22. What is the difference between the Balance of Payment (as % of service exports) in Middle East & North Africa (all income levels) in 2008 and the Balance of Payment (as % of service exports) in Sweden in 2010?
Make the answer very short. 1.76. What is the difference between the Balance of Payment (as % of service exports) in Austria in 2008 and the Balance of Payment (as % of service exports) in Sweden in 2010?
Give a very brief answer. 5.36. What is the difference between the Balance of Payment (as % of service exports) in Lower middle income in 2008 and the Balance of Payment (as % of service exports) in Middle East & North Africa (all income levels) in 2011?
Your response must be concise. -3.64. What is the difference between the Balance of Payment (as % of service exports) of Lower middle income in 2008 and the Balance of Payment (as % of service exports) of Austria in 2011?
Provide a succinct answer. -6.41. What is the difference between the Balance of Payment (as % of service exports) of Lower middle income in 2008 and the Balance of Payment (as % of service exports) of Sweden in 2011?
Your response must be concise. 0.76. What is the difference between the Balance of Payment (as % of service exports) of Middle East & North Africa (all income levels) in 2008 and the Balance of Payment (as % of service exports) of Austria in 2011?
Make the answer very short. -4.32. What is the difference between the Balance of Payment (as % of service exports) in Middle East & North Africa (all income levels) in 2008 and the Balance of Payment (as % of service exports) in Sweden in 2011?
Make the answer very short. 2.85. What is the difference between the Balance of Payment (as % of service exports) of Austria in 2008 and the Balance of Payment (as % of service exports) of Sweden in 2011?
Your response must be concise. 6.46. What is the difference between the Balance of Payment (as % of service exports) of Lower middle income in 2008 and the Balance of Payment (as % of service exports) of Middle East & North Africa (all income levels) in 2012?
Your answer should be compact. -5.19. What is the difference between the Balance of Payment (as % of service exports) in Lower middle income in 2008 and the Balance of Payment (as % of service exports) in Austria in 2012?
Keep it short and to the point. -5.38. What is the difference between the Balance of Payment (as % of service exports) in Middle East & North Africa (all income levels) in 2008 and the Balance of Payment (as % of service exports) in Austria in 2012?
Your answer should be very brief. -3.29. What is the difference between the Balance of Payment (as % of service exports) of Middle East & North Africa (all income levels) in 2008 and the Balance of Payment (as % of service exports) of Sweden in 2012?
Your answer should be very brief. 3.08. What is the difference between the Balance of Payment (as % of service exports) in Austria in 2008 and the Balance of Payment (as % of service exports) in Sweden in 2012?
Offer a very short reply. 6.69. What is the difference between the Balance of Payment (as % of service exports) of Lower middle income in 2009 and the Balance of Payment (as % of service exports) of Middle East & North Africa (all income levels) in 2010?
Offer a very short reply. -1.17. What is the difference between the Balance of Payment (as % of service exports) in Lower middle income in 2009 and the Balance of Payment (as % of service exports) in Austria in 2010?
Make the answer very short. -7.11. What is the difference between the Balance of Payment (as % of service exports) in Lower middle income in 2009 and the Balance of Payment (as % of service exports) in Sweden in 2010?
Offer a very short reply. -1.13. What is the difference between the Balance of Payment (as % of service exports) of Middle East & North Africa (all income levels) in 2009 and the Balance of Payment (as % of service exports) of Austria in 2010?
Keep it short and to the point. -7.95. What is the difference between the Balance of Payment (as % of service exports) in Middle East & North Africa (all income levels) in 2009 and the Balance of Payment (as % of service exports) in Sweden in 2010?
Your answer should be compact. -1.97. What is the difference between the Balance of Payment (as % of service exports) in Austria in 2009 and the Balance of Payment (as % of service exports) in Sweden in 2010?
Ensure brevity in your answer.  3.73. What is the difference between the Balance of Payment (as % of service exports) of Lower middle income in 2009 and the Balance of Payment (as % of service exports) of Middle East & North Africa (all income levels) in 2011?
Ensure brevity in your answer.  -4.44. What is the difference between the Balance of Payment (as % of service exports) in Lower middle income in 2009 and the Balance of Payment (as % of service exports) in Austria in 2011?
Your answer should be compact. -7.2. What is the difference between the Balance of Payment (as % of service exports) of Lower middle income in 2009 and the Balance of Payment (as % of service exports) of Sweden in 2011?
Your response must be concise. -0.03. What is the difference between the Balance of Payment (as % of service exports) of Middle East & North Africa (all income levels) in 2009 and the Balance of Payment (as % of service exports) of Austria in 2011?
Make the answer very short. -8.04. What is the difference between the Balance of Payment (as % of service exports) in Middle East & North Africa (all income levels) in 2009 and the Balance of Payment (as % of service exports) in Sweden in 2011?
Your answer should be very brief. -0.87. What is the difference between the Balance of Payment (as % of service exports) of Austria in 2009 and the Balance of Payment (as % of service exports) of Sweden in 2011?
Your answer should be compact. 4.82. What is the difference between the Balance of Payment (as % of service exports) in Lower middle income in 2009 and the Balance of Payment (as % of service exports) in Middle East & North Africa (all income levels) in 2012?
Your answer should be compact. -5.98. What is the difference between the Balance of Payment (as % of service exports) in Lower middle income in 2009 and the Balance of Payment (as % of service exports) in Austria in 2012?
Provide a succinct answer. -6.17. What is the difference between the Balance of Payment (as % of service exports) of Lower middle income in 2009 and the Balance of Payment (as % of service exports) of Sweden in 2012?
Offer a very short reply. 0.2. What is the difference between the Balance of Payment (as % of service exports) in Middle East & North Africa (all income levels) in 2009 and the Balance of Payment (as % of service exports) in Austria in 2012?
Offer a terse response. -7.02. What is the difference between the Balance of Payment (as % of service exports) in Middle East & North Africa (all income levels) in 2009 and the Balance of Payment (as % of service exports) in Sweden in 2012?
Give a very brief answer. -0.64. What is the difference between the Balance of Payment (as % of service exports) in Austria in 2009 and the Balance of Payment (as % of service exports) in Sweden in 2012?
Your answer should be compact. 5.05. What is the difference between the Balance of Payment (as % of service exports) in Lower middle income in 2010 and the Balance of Payment (as % of service exports) in Middle East & North Africa (all income levels) in 2011?
Offer a very short reply. -4.74. What is the difference between the Balance of Payment (as % of service exports) in Lower middle income in 2010 and the Balance of Payment (as % of service exports) in Austria in 2011?
Give a very brief answer. -7.5. What is the difference between the Balance of Payment (as % of service exports) of Lower middle income in 2010 and the Balance of Payment (as % of service exports) of Sweden in 2011?
Make the answer very short. -0.33. What is the difference between the Balance of Payment (as % of service exports) of Middle East & North Africa (all income levels) in 2010 and the Balance of Payment (as % of service exports) of Austria in 2011?
Offer a terse response. -6.03. What is the difference between the Balance of Payment (as % of service exports) of Middle East & North Africa (all income levels) in 2010 and the Balance of Payment (as % of service exports) of Sweden in 2011?
Give a very brief answer. 1.14. What is the difference between the Balance of Payment (as % of service exports) in Austria in 2010 and the Balance of Payment (as % of service exports) in Sweden in 2011?
Give a very brief answer. 7.08. What is the difference between the Balance of Payment (as % of service exports) in Lower middle income in 2010 and the Balance of Payment (as % of service exports) in Middle East & North Africa (all income levels) in 2012?
Your response must be concise. -6.29. What is the difference between the Balance of Payment (as % of service exports) of Lower middle income in 2010 and the Balance of Payment (as % of service exports) of Austria in 2012?
Your answer should be very brief. -6.48. What is the difference between the Balance of Payment (as % of service exports) of Lower middle income in 2010 and the Balance of Payment (as % of service exports) of Sweden in 2012?
Ensure brevity in your answer.  -0.1. What is the difference between the Balance of Payment (as % of service exports) of Middle East & North Africa (all income levels) in 2010 and the Balance of Payment (as % of service exports) of Austria in 2012?
Your answer should be compact. -5. What is the difference between the Balance of Payment (as % of service exports) of Middle East & North Africa (all income levels) in 2010 and the Balance of Payment (as % of service exports) of Sweden in 2012?
Offer a very short reply. 1.37. What is the difference between the Balance of Payment (as % of service exports) of Austria in 2010 and the Balance of Payment (as % of service exports) of Sweden in 2012?
Your answer should be very brief. 7.31. What is the difference between the Balance of Payment (as % of service exports) in Lower middle income in 2011 and the Balance of Payment (as % of service exports) in Middle East & North Africa (all income levels) in 2012?
Offer a terse response. -4.91. What is the difference between the Balance of Payment (as % of service exports) of Lower middle income in 2011 and the Balance of Payment (as % of service exports) of Austria in 2012?
Make the answer very short. -5.1. What is the difference between the Balance of Payment (as % of service exports) in Lower middle income in 2011 and the Balance of Payment (as % of service exports) in Sweden in 2012?
Offer a terse response. 1.28. What is the difference between the Balance of Payment (as % of service exports) in Middle East & North Africa (all income levels) in 2011 and the Balance of Payment (as % of service exports) in Austria in 2012?
Offer a very short reply. -1.74. What is the difference between the Balance of Payment (as % of service exports) in Middle East & North Africa (all income levels) in 2011 and the Balance of Payment (as % of service exports) in Sweden in 2012?
Offer a very short reply. 4.63. What is the difference between the Balance of Payment (as % of service exports) of Austria in 2011 and the Balance of Payment (as % of service exports) of Sweden in 2012?
Provide a succinct answer. 7.4. What is the average Balance of Payment (as % of service exports) of Lower middle income per year?
Provide a short and direct response. 19.02. What is the average Balance of Payment (as % of service exports) of Middle East & North Africa (all income levels) per year?
Your answer should be compact. 20.93. What is the average Balance of Payment (as % of service exports) in Austria per year?
Provide a succinct answer. 24.29. What is the average Balance of Payment (as % of service exports) in Sweden per year?
Provide a short and direct response. 20.01. In the year 2005, what is the difference between the Balance of Payment (as % of service exports) in Lower middle income and Balance of Payment (as % of service exports) in Middle East & North Africa (all income levels)?
Make the answer very short. -0.84. In the year 2005, what is the difference between the Balance of Payment (as % of service exports) in Lower middle income and Balance of Payment (as % of service exports) in Austria?
Give a very brief answer. 0.52. In the year 2005, what is the difference between the Balance of Payment (as % of service exports) in Lower middle income and Balance of Payment (as % of service exports) in Sweden?
Provide a succinct answer. 0.46. In the year 2005, what is the difference between the Balance of Payment (as % of service exports) of Middle East & North Africa (all income levels) and Balance of Payment (as % of service exports) of Austria?
Make the answer very short. 1.35. In the year 2005, what is the difference between the Balance of Payment (as % of service exports) of Middle East & North Africa (all income levels) and Balance of Payment (as % of service exports) of Sweden?
Give a very brief answer. 1.29. In the year 2005, what is the difference between the Balance of Payment (as % of service exports) of Austria and Balance of Payment (as % of service exports) of Sweden?
Your response must be concise. -0.06. In the year 2006, what is the difference between the Balance of Payment (as % of service exports) of Lower middle income and Balance of Payment (as % of service exports) of Middle East & North Africa (all income levels)?
Keep it short and to the point. -0.65. In the year 2006, what is the difference between the Balance of Payment (as % of service exports) of Lower middle income and Balance of Payment (as % of service exports) of Austria?
Offer a terse response. -5.75. In the year 2006, what is the difference between the Balance of Payment (as % of service exports) of Lower middle income and Balance of Payment (as % of service exports) of Sweden?
Ensure brevity in your answer.  -1.42. In the year 2006, what is the difference between the Balance of Payment (as % of service exports) of Middle East & North Africa (all income levels) and Balance of Payment (as % of service exports) of Austria?
Ensure brevity in your answer.  -5.1. In the year 2006, what is the difference between the Balance of Payment (as % of service exports) in Middle East & North Africa (all income levels) and Balance of Payment (as % of service exports) in Sweden?
Provide a short and direct response. -0.77. In the year 2006, what is the difference between the Balance of Payment (as % of service exports) in Austria and Balance of Payment (as % of service exports) in Sweden?
Give a very brief answer. 4.33. In the year 2007, what is the difference between the Balance of Payment (as % of service exports) in Lower middle income and Balance of Payment (as % of service exports) in Middle East & North Africa (all income levels)?
Keep it short and to the point. -2.01. In the year 2007, what is the difference between the Balance of Payment (as % of service exports) in Lower middle income and Balance of Payment (as % of service exports) in Austria?
Keep it short and to the point. -6.93. In the year 2007, what is the difference between the Balance of Payment (as % of service exports) of Lower middle income and Balance of Payment (as % of service exports) of Sweden?
Ensure brevity in your answer.  -2.29. In the year 2007, what is the difference between the Balance of Payment (as % of service exports) in Middle East & North Africa (all income levels) and Balance of Payment (as % of service exports) in Austria?
Provide a succinct answer. -4.92. In the year 2007, what is the difference between the Balance of Payment (as % of service exports) in Middle East & North Africa (all income levels) and Balance of Payment (as % of service exports) in Sweden?
Ensure brevity in your answer.  -0.28. In the year 2007, what is the difference between the Balance of Payment (as % of service exports) in Austria and Balance of Payment (as % of service exports) in Sweden?
Provide a succinct answer. 4.64. In the year 2008, what is the difference between the Balance of Payment (as % of service exports) in Lower middle income and Balance of Payment (as % of service exports) in Middle East & North Africa (all income levels)?
Your answer should be compact. -2.09. In the year 2008, what is the difference between the Balance of Payment (as % of service exports) in Lower middle income and Balance of Payment (as % of service exports) in Austria?
Make the answer very short. -5.7. In the year 2008, what is the difference between the Balance of Payment (as % of service exports) in Lower middle income and Balance of Payment (as % of service exports) in Sweden?
Offer a terse response. -2.66. In the year 2008, what is the difference between the Balance of Payment (as % of service exports) in Middle East & North Africa (all income levels) and Balance of Payment (as % of service exports) in Austria?
Keep it short and to the point. -3.6. In the year 2008, what is the difference between the Balance of Payment (as % of service exports) in Middle East & North Africa (all income levels) and Balance of Payment (as % of service exports) in Sweden?
Offer a very short reply. -0.57. In the year 2008, what is the difference between the Balance of Payment (as % of service exports) in Austria and Balance of Payment (as % of service exports) in Sweden?
Offer a terse response. 3.04. In the year 2009, what is the difference between the Balance of Payment (as % of service exports) in Lower middle income and Balance of Payment (as % of service exports) in Middle East & North Africa (all income levels)?
Give a very brief answer. 0.84. In the year 2009, what is the difference between the Balance of Payment (as % of service exports) in Lower middle income and Balance of Payment (as % of service exports) in Austria?
Provide a succinct answer. -4.85. In the year 2009, what is the difference between the Balance of Payment (as % of service exports) of Lower middle income and Balance of Payment (as % of service exports) of Sweden?
Offer a very short reply. -2.07. In the year 2009, what is the difference between the Balance of Payment (as % of service exports) in Middle East & North Africa (all income levels) and Balance of Payment (as % of service exports) in Austria?
Ensure brevity in your answer.  -5.7. In the year 2009, what is the difference between the Balance of Payment (as % of service exports) in Middle East & North Africa (all income levels) and Balance of Payment (as % of service exports) in Sweden?
Offer a very short reply. -2.91. In the year 2009, what is the difference between the Balance of Payment (as % of service exports) in Austria and Balance of Payment (as % of service exports) in Sweden?
Offer a very short reply. 2.79. In the year 2010, what is the difference between the Balance of Payment (as % of service exports) in Lower middle income and Balance of Payment (as % of service exports) in Middle East & North Africa (all income levels)?
Give a very brief answer. -1.47. In the year 2010, what is the difference between the Balance of Payment (as % of service exports) in Lower middle income and Balance of Payment (as % of service exports) in Austria?
Give a very brief answer. -7.41. In the year 2010, what is the difference between the Balance of Payment (as % of service exports) in Lower middle income and Balance of Payment (as % of service exports) in Sweden?
Provide a short and direct response. -1.43. In the year 2010, what is the difference between the Balance of Payment (as % of service exports) of Middle East & North Africa (all income levels) and Balance of Payment (as % of service exports) of Austria?
Your answer should be very brief. -5.93. In the year 2010, what is the difference between the Balance of Payment (as % of service exports) of Middle East & North Africa (all income levels) and Balance of Payment (as % of service exports) of Sweden?
Offer a terse response. 0.05. In the year 2010, what is the difference between the Balance of Payment (as % of service exports) in Austria and Balance of Payment (as % of service exports) in Sweden?
Make the answer very short. 5.98. In the year 2011, what is the difference between the Balance of Payment (as % of service exports) of Lower middle income and Balance of Payment (as % of service exports) of Middle East & North Africa (all income levels)?
Keep it short and to the point. -3.36. In the year 2011, what is the difference between the Balance of Payment (as % of service exports) of Lower middle income and Balance of Payment (as % of service exports) of Austria?
Your answer should be very brief. -6.12. In the year 2011, what is the difference between the Balance of Payment (as % of service exports) of Lower middle income and Balance of Payment (as % of service exports) of Sweden?
Offer a terse response. 1.04. In the year 2011, what is the difference between the Balance of Payment (as % of service exports) in Middle East & North Africa (all income levels) and Balance of Payment (as % of service exports) in Austria?
Make the answer very short. -2.77. In the year 2011, what is the difference between the Balance of Payment (as % of service exports) in Middle East & North Africa (all income levels) and Balance of Payment (as % of service exports) in Sweden?
Provide a succinct answer. 4.4. In the year 2011, what is the difference between the Balance of Payment (as % of service exports) of Austria and Balance of Payment (as % of service exports) of Sweden?
Keep it short and to the point. 7.17. In the year 2012, what is the difference between the Balance of Payment (as % of service exports) in Lower middle income and Balance of Payment (as % of service exports) in Middle East & North Africa (all income levels)?
Your response must be concise. -5.71. In the year 2012, what is the difference between the Balance of Payment (as % of service exports) in Lower middle income and Balance of Payment (as % of service exports) in Austria?
Offer a terse response. -5.9. In the year 2012, what is the difference between the Balance of Payment (as % of service exports) of Lower middle income and Balance of Payment (as % of service exports) of Sweden?
Your answer should be very brief. 0.47. In the year 2012, what is the difference between the Balance of Payment (as % of service exports) of Middle East & North Africa (all income levels) and Balance of Payment (as % of service exports) of Austria?
Make the answer very short. -0.19. In the year 2012, what is the difference between the Balance of Payment (as % of service exports) in Middle East & North Africa (all income levels) and Balance of Payment (as % of service exports) in Sweden?
Provide a succinct answer. 6.18. In the year 2012, what is the difference between the Balance of Payment (as % of service exports) in Austria and Balance of Payment (as % of service exports) in Sweden?
Your answer should be compact. 6.37. What is the ratio of the Balance of Payment (as % of service exports) of Middle East & North Africa (all income levels) in 2005 to that in 2006?
Keep it short and to the point. 1.03. What is the ratio of the Balance of Payment (as % of service exports) of Austria in 2005 to that in 2006?
Your response must be concise. 0.77. What is the ratio of the Balance of Payment (as % of service exports) of Sweden in 2005 to that in 2006?
Ensure brevity in your answer.  0.93. What is the ratio of the Balance of Payment (as % of service exports) in Lower middle income in 2005 to that in 2007?
Make the answer very short. 1.11. What is the ratio of the Balance of Payment (as % of service exports) of Middle East & North Africa (all income levels) in 2005 to that in 2007?
Your answer should be very brief. 1.04. What is the ratio of the Balance of Payment (as % of service exports) in Austria in 2005 to that in 2007?
Make the answer very short. 0.79. What is the ratio of the Balance of Payment (as % of service exports) in Lower middle income in 2005 to that in 2008?
Keep it short and to the point. 1.07. What is the ratio of the Balance of Payment (as % of service exports) in Austria in 2005 to that in 2008?
Offer a terse response. 0.81. What is the ratio of the Balance of Payment (as % of service exports) in Sweden in 2005 to that in 2008?
Provide a short and direct response. 0.92. What is the ratio of the Balance of Payment (as % of service exports) in Lower middle income in 2005 to that in 2009?
Ensure brevity in your answer.  1.12. What is the ratio of the Balance of Payment (as % of service exports) of Middle East & North Africa (all income levels) in 2005 to that in 2009?
Your answer should be very brief. 1.22. What is the ratio of the Balance of Payment (as % of service exports) of Austria in 2005 to that in 2009?
Make the answer very short. 0.86. What is the ratio of the Balance of Payment (as % of service exports) in Sweden in 2005 to that in 2009?
Your answer should be compact. 0.98. What is the ratio of the Balance of Payment (as % of service exports) of Lower middle income in 2005 to that in 2010?
Provide a succinct answer. 1.14. What is the ratio of the Balance of Payment (as % of service exports) of Middle East & North Africa (all income levels) in 2005 to that in 2010?
Your answer should be very brief. 1.1. What is the ratio of the Balance of Payment (as % of service exports) of Austria in 2005 to that in 2010?
Offer a terse response. 0.79. What is the ratio of the Balance of Payment (as % of service exports) of Sweden in 2005 to that in 2010?
Give a very brief answer. 1.03. What is the ratio of the Balance of Payment (as % of service exports) of Lower middle income in 2005 to that in 2011?
Your response must be concise. 1.06. What is the ratio of the Balance of Payment (as % of service exports) of Middle East & North Africa (all income levels) in 2005 to that in 2011?
Keep it short and to the point. 0.94. What is the ratio of the Balance of Payment (as % of service exports) in Austria in 2005 to that in 2011?
Give a very brief answer. 0.78. What is the ratio of the Balance of Payment (as % of service exports) in Sweden in 2005 to that in 2011?
Your response must be concise. 1.09. What is the ratio of the Balance of Payment (as % of service exports) of Lower middle income in 2005 to that in 2012?
Your answer should be very brief. 1.1. What is the ratio of the Balance of Payment (as % of service exports) of Middle East & North Africa (all income levels) in 2005 to that in 2012?
Offer a terse response. 0.88. What is the ratio of the Balance of Payment (as % of service exports) of Austria in 2005 to that in 2012?
Provide a succinct answer. 0.82. What is the ratio of the Balance of Payment (as % of service exports) in Sweden in 2005 to that in 2012?
Provide a short and direct response. 1.11. What is the ratio of the Balance of Payment (as % of service exports) of Lower middle income in 2006 to that in 2007?
Provide a succinct answer. 1.09. What is the ratio of the Balance of Payment (as % of service exports) of Middle East & North Africa (all income levels) in 2006 to that in 2007?
Make the answer very short. 1.01. What is the ratio of the Balance of Payment (as % of service exports) in Austria in 2006 to that in 2007?
Offer a very short reply. 1.02. What is the ratio of the Balance of Payment (as % of service exports) of Sweden in 2006 to that in 2007?
Your answer should be compact. 1.04. What is the ratio of the Balance of Payment (as % of service exports) in Lower middle income in 2006 to that in 2008?
Your response must be concise. 1.05. What is the ratio of the Balance of Payment (as % of service exports) in Middle East & North Africa (all income levels) in 2006 to that in 2008?
Give a very brief answer. 0.98. What is the ratio of the Balance of Payment (as % of service exports) in Austria in 2006 to that in 2008?
Offer a very short reply. 1.04. What is the ratio of the Balance of Payment (as % of service exports) of Sweden in 2006 to that in 2008?
Offer a very short reply. 0.99. What is the ratio of the Balance of Payment (as % of service exports) of Lower middle income in 2006 to that in 2009?
Make the answer very short. 1.1. What is the ratio of the Balance of Payment (as % of service exports) of Middle East & North Africa (all income levels) in 2006 to that in 2009?
Ensure brevity in your answer.  1.19. What is the ratio of the Balance of Payment (as % of service exports) of Austria in 2006 to that in 2009?
Your answer should be compact. 1.12. What is the ratio of the Balance of Payment (as % of service exports) in Sweden in 2006 to that in 2009?
Your answer should be very brief. 1.06. What is the ratio of the Balance of Payment (as % of service exports) of Lower middle income in 2006 to that in 2010?
Offer a very short reply. 1.12. What is the ratio of the Balance of Payment (as % of service exports) of Middle East & North Africa (all income levels) in 2006 to that in 2010?
Your answer should be very brief. 1.07. What is the ratio of the Balance of Payment (as % of service exports) in Austria in 2006 to that in 2010?
Provide a short and direct response. 1.02. What is the ratio of the Balance of Payment (as % of service exports) of Sweden in 2006 to that in 2010?
Provide a succinct answer. 1.11. What is the ratio of the Balance of Payment (as % of service exports) in Lower middle income in 2006 to that in 2011?
Keep it short and to the point. 1.04. What is the ratio of the Balance of Payment (as % of service exports) in Middle East & North Africa (all income levels) in 2006 to that in 2011?
Your response must be concise. 0.91. What is the ratio of the Balance of Payment (as % of service exports) in Austria in 2006 to that in 2011?
Provide a succinct answer. 1.01. What is the ratio of the Balance of Payment (as % of service exports) of Sweden in 2006 to that in 2011?
Provide a succinct answer. 1.17. What is the ratio of the Balance of Payment (as % of service exports) of Lower middle income in 2006 to that in 2012?
Keep it short and to the point. 1.08. What is the ratio of the Balance of Payment (as % of service exports) of Middle East & North Africa (all income levels) in 2006 to that in 2012?
Your answer should be very brief. 0.85. What is the ratio of the Balance of Payment (as % of service exports) in Austria in 2006 to that in 2012?
Give a very brief answer. 1.06. What is the ratio of the Balance of Payment (as % of service exports) in Sweden in 2006 to that in 2012?
Give a very brief answer. 1.19. What is the ratio of the Balance of Payment (as % of service exports) of Lower middle income in 2007 to that in 2008?
Your answer should be compact. 0.97. What is the ratio of the Balance of Payment (as % of service exports) of Middle East & North Africa (all income levels) in 2007 to that in 2008?
Give a very brief answer. 0.97. What is the ratio of the Balance of Payment (as % of service exports) in Austria in 2007 to that in 2008?
Provide a succinct answer. 1.03. What is the ratio of the Balance of Payment (as % of service exports) in Sweden in 2007 to that in 2008?
Your answer should be very brief. 0.96. What is the ratio of the Balance of Payment (as % of service exports) of Lower middle income in 2007 to that in 2009?
Provide a short and direct response. 1.01. What is the ratio of the Balance of Payment (as % of service exports) in Middle East & North Africa (all income levels) in 2007 to that in 2009?
Provide a succinct answer. 1.17. What is the ratio of the Balance of Payment (as % of service exports) of Austria in 2007 to that in 2009?
Offer a very short reply. 1.1. What is the ratio of the Balance of Payment (as % of service exports) of Sweden in 2007 to that in 2009?
Keep it short and to the point. 1.02. What is the ratio of the Balance of Payment (as % of service exports) of Lower middle income in 2007 to that in 2010?
Provide a succinct answer. 1.03. What is the ratio of the Balance of Payment (as % of service exports) of Middle East & North Africa (all income levels) in 2007 to that in 2010?
Offer a terse response. 1.05. What is the ratio of the Balance of Payment (as % of service exports) in Austria in 2007 to that in 2010?
Give a very brief answer. 1. What is the ratio of the Balance of Payment (as % of service exports) in Sweden in 2007 to that in 2010?
Provide a short and direct response. 1.07. What is the ratio of the Balance of Payment (as % of service exports) of Lower middle income in 2007 to that in 2011?
Offer a very short reply. 0.95. What is the ratio of the Balance of Payment (as % of service exports) in Middle East & North Africa (all income levels) in 2007 to that in 2011?
Your response must be concise. 0.9. What is the ratio of the Balance of Payment (as % of service exports) of Austria in 2007 to that in 2011?
Give a very brief answer. 1. What is the ratio of the Balance of Payment (as % of service exports) of Sweden in 2007 to that in 2011?
Keep it short and to the point. 1.13. What is the ratio of the Balance of Payment (as % of service exports) in Middle East & North Africa (all income levels) in 2007 to that in 2012?
Offer a terse response. 0.84. What is the ratio of the Balance of Payment (as % of service exports) of Austria in 2007 to that in 2012?
Your answer should be very brief. 1.04. What is the ratio of the Balance of Payment (as % of service exports) in Sweden in 2007 to that in 2012?
Provide a succinct answer. 1.15. What is the ratio of the Balance of Payment (as % of service exports) of Lower middle income in 2008 to that in 2009?
Keep it short and to the point. 1.04. What is the ratio of the Balance of Payment (as % of service exports) in Middle East & North Africa (all income levels) in 2008 to that in 2009?
Ensure brevity in your answer.  1.21. What is the ratio of the Balance of Payment (as % of service exports) of Austria in 2008 to that in 2009?
Give a very brief answer. 1.07. What is the ratio of the Balance of Payment (as % of service exports) of Sweden in 2008 to that in 2009?
Offer a very short reply. 1.07. What is the ratio of the Balance of Payment (as % of service exports) of Lower middle income in 2008 to that in 2010?
Your response must be concise. 1.06. What is the ratio of the Balance of Payment (as % of service exports) in Middle East & North Africa (all income levels) in 2008 to that in 2010?
Your answer should be compact. 1.09. What is the ratio of the Balance of Payment (as % of service exports) of Austria in 2008 to that in 2010?
Offer a terse response. 0.98. What is the ratio of the Balance of Payment (as % of service exports) in Sweden in 2008 to that in 2010?
Provide a succinct answer. 1.12. What is the ratio of the Balance of Payment (as % of service exports) of Middle East & North Africa (all income levels) in 2008 to that in 2011?
Your response must be concise. 0.93. What is the ratio of the Balance of Payment (as % of service exports) in Sweden in 2008 to that in 2011?
Your response must be concise. 1.19. What is the ratio of the Balance of Payment (as % of service exports) in Lower middle income in 2008 to that in 2012?
Your response must be concise. 1.03. What is the ratio of the Balance of Payment (as % of service exports) of Middle East & North Africa (all income levels) in 2008 to that in 2012?
Provide a short and direct response. 0.87. What is the ratio of the Balance of Payment (as % of service exports) in Austria in 2008 to that in 2012?
Ensure brevity in your answer.  1.01. What is the ratio of the Balance of Payment (as % of service exports) in Sweden in 2008 to that in 2012?
Offer a terse response. 1.2. What is the ratio of the Balance of Payment (as % of service exports) in Lower middle income in 2009 to that in 2010?
Ensure brevity in your answer.  1.02. What is the ratio of the Balance of Payment (as % of service exports) of Middle East & North Africa (all income levels) in 2009 to that in 2010?
Offer a terse response. 0.9. What is the ratio of the Balance of Payment (as % of service exports) of Austria in 2009 to that in 2010?
Provide a succinct answer. 0.91. What is the ratio of the Balance of Payment (as % of service exports) in Sweden in 2009 to that in 2010?
Make the answer very short. 1.05. What is the ratio of the Balance of Payment (as % of service exports) in Middle East & North Africa (all income levels) in 2009 to that in 2011?
Your answer should be compact. 0.77. What is the ratio of the Balance of Payment (as % of service exports) in Austria in 2009 to that in 2011?
Your answer should be compact. 0.91. What is the ratio of the Balance of Payment (as % of service exports) of Sweden in 2009 to that in 2011?
Make the answer very short. 1.11. What is the ratio of the Balance of Payment (as % of service exports) in Lower middle income in 2009 to that in 2012?
Your answer should be compact. 0.99. What is the ratio of the Balance of Payment (as % of service exports) in Middle East & North Africa (all income levels) in 2009 to that in 2012?
Your answer should be very brief. 0.72. What is the ratio of the Balance of Payment (as % of service exports) in Austria in 2009 to that in 2012?
Make the answer very short. 0.95. What is the ratio of the Balance of Payment (as % of service exports) of Sweden in 2009 to that in 2012?
Your response must be concise. 1.13. What is the ratio of the Balance of Payment (as % of service exports) of Lower middle income in 2010 to that in 2011?
Your response must be concise. 0.93. What is the ratio of the Balance of Payment (as % of service exports) of Middle East & North Africa (all income levels) in 2010 to that in 2011?
Provide a succinct answer. 0.86. What is the ratio of the Balance of Payment (as % of service exports) of Sweden in 2010 to that in 2011?
Provide a succinct answer. 1.06. What is the ratio of the Balance of Payment (as % of service exports) in Lower middle income in 2010 to that in 2012?
Provide a succinct answer. 0.97. What is the ratio of the Balance of Payment (as % of service exports) in Middle East & North Africa (all income levels) in 2010 to that in 2012?
Offer a very short reply. 0.8. What is the ratio of the Balance of Payment (as % of service exports) in Austria in 2010 to that in 2012?
Provide a short and direct response. 1.04. What is the ratio of the Balance of Payment (as % of service exports) of Sweden in 2010 to that in 2012?
Give a very brief answer. 1.07. What is the ratio of the Balance of Payment (as % of service exports) of Lower middle income in 2011 to that in 2012?
Offer a terse response. 1.04. What is the ratio of the Balance of Payment (as % of service exports) of Middle East & North Africa (all income levels) in 2011 to that in 2012?
Offer a very short reply. 0.94. What is the ratio of the Balance of Payment (as % of service exports) of Austria in 2011 to that in 2012?
Ensure brevity in your answer.  1.04. What is the ratio of the Balance of Payment (as % of service exports) in Sweden in 2011 to that in 2012?
Offer a terse response. 1.01. What is the difference between the highest and the second highest Balance of Payment (as % of service exports) of Lower middle income?
Your answer should be very brief. 0.38. What is the difference between the highest and the second highest Balance of Payment (as % of service exports) in Middle East & North Africa (all income levels)?
Offer a terse response. 1.55. What is the difference between the highest and the second highest Balance of Payment (as % of service exports) in Austria?
Offer a terse response. 0.36. What is the difference between the highest and the second highest Balance of Payment (as % of service exports) of Sweden?
Your response must be concise. 0.22. What is the difference between the highest and the lowest Balance of Payment (as % of service exports) of Lower middle income?
Ensure brevity in your answer.  2.5. What is the difference between the highest and the lowest Balance of Payment (as % of service exports) in Middle East & North Africa (all income levels)?
Give a very brief answer. 6.83. What is the difference between the highest and the lowest Balance of Payment (as % of service exports) of Austria?
Make the answer very short. 5.88. What is the difference between the highest and the lowest Balance of Payment (as % of service exports) of Sweden?
Offer a very short reply. 3.65. 